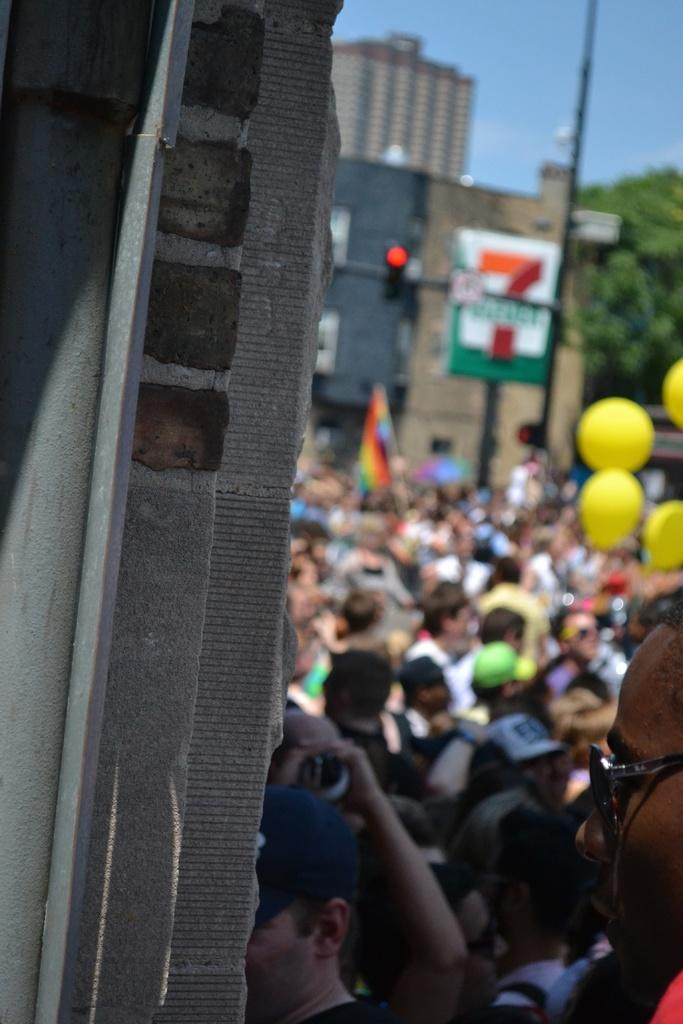What type of structures can be seen in the image? There are buildings in the image. What else is present in the image besides the buildings? There are people standing, balloons, a tree, a hoarding board on a pole, and a flag in the image. What is the condition of the sky in the image? The sky is cloudy in the image. What type of tin is being used to store the quartz in the image? There is no tin or quartz present in the image. What is the mind doing in the image? The concept of a "mind" is not a physical object or entity that can be seen in the image. 